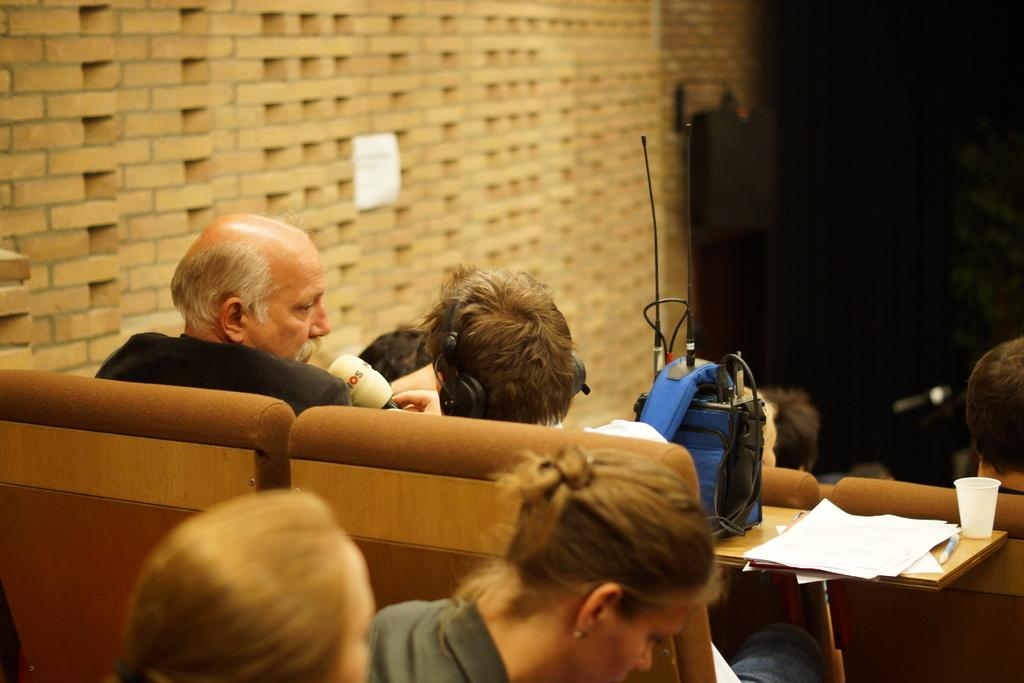What are the people in the image doing? The people are sitting on chairs. What can be seen on the table in the image? There are papers, a glass, and a blue color bag on the table. What type of material is the wall made of in the image? The wall in the image is made of bricks. How would you describe the lighting in the image? The background appears dark in the image. What force is causing the people to run in the image? There is no indication in the image that the people are running, and therefore no force can be identified. 